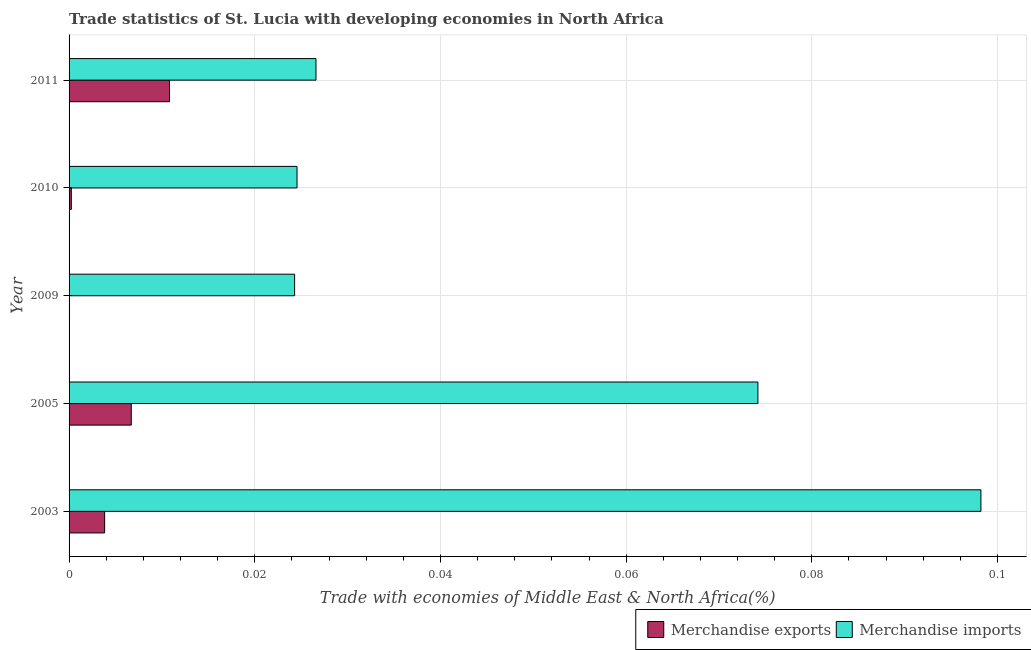How many groups of bars are there?
Ensure brevity in your answer.  5. Are the number of bars on each tick of the Y-axis equal?
Keep it short and to the point. Yes. How many bars are there on the 3rd tick from the top?
Your response must be concise. 2. How many bars are there on the 3rd tick from the bottom?
Your answer should be compact. 2. What is the label of the 1st group of bars from the top?
Your answer should be very brief. 2011. In how many cases, is the number of bars for a given year not equal to the number of legend labels?
Keep it short and to the point. 0. What is the merchandise imports in 2005?
Your answer should be very brief. 0.07. Across all years, what is the maximum merchandise imports?
Provide a succinct answer. 0.1. Across all years, what is the minimum merchandise imports?
Make the answer very short. 0.02. What is the total merchandise exports in the graph?
Ensure brevity in your answer.  0.02. What is the difference between the merchandise exports in 2009 and that in 2010?
Make the answer very short. -0. What is the difference between the merchandise exports in 2009 and the merchandise imports in 2003?
Make the answer very short. -0.1. What is the average merchandise imports per year?
Provide a short and direct response. 0.05. In the year 2003, what is the difference between the merchandise exports and merchandise imports?
Offer a terse response. -0.09. In how many years, is the merchandise exports greater than 0.056 %?
Your answer should be very brief. 0. What is the ratio of the merchandise exports in 2003 to that in 2009?
Ensure brevity in your answer.  79.5. Is the merchandise imports in 2003 less than that in 2009?
Offer a very short reply. No. What is the difference between the highest and the second highest merchandise exports?
Make the answer very short. 0. What is the difference between the highest and the lowest merchandise imports?
Make the answer very short. 0.07. Is the sum of the merchandise imports in 2005 and 2009 greater than the maximum merchandise exports across all years?
Ensure brevity in your answer.  Yes. What does the 2nd bar from the top in 2009 represents?
Make the answer very short. Merchandise exports. What does the 2nd bar from the bottom in 2011 represents?
Keep it short and to the point. Merchandise imports. Are all the bars in the graph horizontal?
Offer a very short reply. Yes. How many years are there in the graph?
Provide a succinct answer. 5. What is the difference between two consecutive major ticks on the X-axis?
Your response must be concise. 0.02. Does the graph contain any zero values?
Your answer should be very brief. No. Does the graph contain grids?
Your response must be concise. Yes. Where does the legend appear in the graph?
Keep it short and to the point. Bottom right. What is the title of the graph?
Provide a short and direct response. Trade statistics of St. Lucia with developing economies in North Africa. What is the label or title of the X-axis?
Make the answer very short. Trade with economies of Middle East & North Africa(%). What is the label or title of the Y-axis?
Your response must be concise. Year. What is the Trade with economies of Middle East & North Africa(%) in Merchandise exports in 2003?
Keep it short and to the point. 0. What is the Trade with economies of Middle East & North Africa(%) in Merchandise imports in 2003?
Provide a succinct answer. 0.1. What is the Trade with economies of Middle East & North Africa(%) of Merchandise exports in 2005?
Offer a terse response. 0.01. What is the Trade with economies of Middle East & North Africa(%) of Merchandise imports in 2005?
Give a very brief answer. 0.07. What is the Trade with economies of Middle East & North Africa(%) in Merchandise exports in 2009?
Keep it short and to the point. 4.81975497009493e-5. What is the Trade with economies of Middle East & North Africa(%) of Merchandise imports in 2009?
Your response must be concise. 0.02. What is the Trade with economies of Middle East & North Africa(%) of Merchandise exports in 2010?
Your answer should be very brief. 0. What is the Trade with economies of Middle East & North Africa(%) of Merchandise imports in 2010?
Make the answer very short. 0.02. What is the Trade with economies of Middle East & North Africa(%) of Merchandise exports in 2011?
Offer a terse response. 0.01. What is the Trade with economies of Middle East & North Africa(%) of Merchandise imports in 2011?
Keep it short and to the point. 0.03. Across all years, what is the maximum Trade with economies of Middle East & North Africa(%) in Merchandise exports?
Provide a succinct answer. 0.01. Across all years, what is the maximum Trade with economies of Middle East & North Africa(%) of Merchandise imports?
Your response must be concise. 0.1. Across all years, what is the minimum Trade with economies of Middle East & North Africa(%) in Merchandise exports?
Your answer should be very brief. 4.81975497009493e-5. Across all years, what is the minimum Trade with economies of Middle East & North Africa(%) of Merchandise imports?
Offer a terse response. 0.02. What is the total Trade with economies of Middle East & North Africa(%) of Merchandise exports in the graph?
Keep it short and to the point. 0.02. What is the total Trade with economies of Middle East & North Africa(%) in Merchandise imports in the graph?
Offer a very short reply. 0.25. What is the difference between the Trade with economies of Middle East & North Africa(%) of Merchandise exports in 2003 and that in 2005?
Give a very brief answer. -0. What is the difference between the Trade with economies of Middle East & North Africa(%) in Merchandise imports in 2003 and that in 2005?
Make the answer very short. 0.02. What is the difference between the Trade with economies of Middle East & North Africa(%) in Merchandise exports in 2003 and that in 2009?
Keep it short and to the point. 0. What is the difference between the Trade with economies of Middle East & North Africa(%) of Merchandise imports in 2003 and that in 2009?
Make the answer very short. 0.07. What is the difference between the Trade with economies of Middle East & North Africa(%) of Merchandise exports in 2003 and that in 2010?
Provide a short and direct response. 0. What is the difference between the Trade with economies of Middle East & North Africa(%) in Merchandise imports in 2003 and that in 2010?
Provide a succinct answer. 0.07. What is the difference between the Trade with economies of Middle East & North Africa(%) of Merchandise exports in 2003 and that in 2011?
Offer a very short reply. -0.01. What is the difference between the Trade with economies of Middle East & North Africa(%) of Merchandise imports in 2003 and that in 2011?
Provide a succinct answer. 0.07. What is the difference between the Trade with economies of Middle East & North Africa(%) in Merchandise exports in 2005 and that in 2009?
Ensure brevity in your answer.  0.01. What is the difference between the Trade with economies of Middle East & North Africa(%) of Merchandise imports in 2005 and that in 2009?
Offer a very short reply. 0.05. What is the difference between the Trade with economies of Middle East & North Africa(%) in Merchandise exports in 2005 and that in 2010?
Your answer should be compact. 0.01. What is the difference between the Trade with economies of Middle East & North Africa(%) in Merchandise imports in 2005 and that in 2010?
Give a very brief answer. 0.05. What is the difference between the Trade with economies of Middle East & North Africa(%) of Merchandise exports in 2005 and that in 2011?
Make the answer very short. -0. What is the difference between the Trade with economies of Middle East & North Africa(%) of Merchandise imports in 2005 and that in 2011?
Provide a succinct answer. 0.05. What is the difference between the Trade with economies of Middle East & North Africa(%) in Merchandise exports in 2009 and that in 2010?
Provide a succinct answer. -0. What is the difference between the Trade with economies of Middle East & North Africa(%) in Merchandise imports in 2009 and that in 2010?
Your answer should be very brief. -0. What is the difference between the Trade with economies of Middle East & North Africa(%) of Merchandise exports in 2009 and that in 2011?
Provide a succinct answer. -0.01. What is the difference between the Trade with economies of Middle East & North Africa(%) of Merchandise imports in 2009 and that in 2011?
Your response must be concise. -0. What is the difference between the Trade with economies of Middle East & North Africa(%) in Merchandise exports in 2010 and that in 2011?
Offer a very short reply. -0.01. What is the difference between the Trade with economies of Middle East & North Africa(%) of Merchandise imports in 2010 and that in 2011?
Provide a succinct answer. -0. What is the difference between the Trade with economies of Middle East & North Africa(%) in Merchandise exports in 2003 and the Trade with economies of Middle East & North Africa(%) in Merchandise imports in 2005?
Give a very brief answer. -0.07. What is the difference between the Trade with economies of Middle East & North Africa(%) in Merchandise exports in 2003 and the Trade with economies of Middle East & North Africa(%) in Merchandise imports in 2009?
Offer a very short reply. -0.02. What is the difference between the Trade with economies of Middle East & North Africa(%) in Merchandise exports in 2003 and the Trade with economies of Middle East & North Africa(%) in Merchandise imports in 2010?
Your answer should be compact. -0.02. What is the difference between the Trade with economies of Middle East & North Africa(%) in Merchandise exports in 2003 and the Trade with economies of Middle East & North Africa(%) in Merchandise imports in 2011?
Your answer should be very brief. -0.02. What is the difference between the Trade with economies of Middle East & North Africa(%) in Merchandise exports in 2005 and the Trade with economies of Middle East & North Africa(%) in Merchandise imports in 2009?
Provide a succinct answer. -0.02. What is the difference between the Trade with economies of Middle East & North Africa(%) in Merchandise exports in 2005 and the Trade with economies of Middle East & North Africa(%) in Merchandise imports in 2010?
Ensure brevity in your answer.  -0.02. What is the difference between the Trade with economies of Middle East & North Africa(%) of Merchandise exports in 2005 and the Trade with economies of Middle East & North Africa(%) of Merchandise imports in 2011?
Ensure brevity in your answer.  -0.02. What is the difference between the Trade with economies of Middle East & North Africa(%) of Merchandise exports in 2009 and the Trade with economies of Middle East & North Africa(%) of Merchandise imports in 2010?
Keep it short and to the point. -0.02. What is the difference between the Trade with economies of Middle East & North Africa(%) of Merchandise exports in 2009 and the Trade with economies of Middle East & North Africa(%) of Merchandise imports in 2011?
Your answer should be very brief. -0.03. What is the difference between the Trade with economies of Middle East & North Africa(%) of Merchandise exports in 2010 and the Trade with economies of Middle East & North Africa(%) of Merchandise imports in 2011?
Offer a terse response. -0.03. What is the average Trade with economies of Middle East & North Africa(%) in Merchandise exports per year?
Provide a short and direct response. 0. What is the average Trade with economies of Middle East & North Africa(%) of Merchandise imports per year?
Keep it short and to the point. 0.05. In the year 2003, what is the difference between the Trade with economies of Middle East & North Africa(%) in Merchandise exports and Trade with economies of Middle East & North Africa(%) in Merchandise imports?
Provide a short and direct response. -0.09. In the year 2005, what is the difference between the Trade with economies of Middle East & North Africa(%) of Merchandise exports and Trade with economies of Middle East & North Africa(%) of Merchandise imports?
Your response must be concise. -0.07. In the year 2009, what is the difference between the Trade with economies of Middle East & North Africa(%) of Merchandise exports and Trade with economies of Middle East & North Africa(%) of Merchandise imports?
Give a very brief answer. -0.02. In the year 2010, what is the difference between the Trade with economies of Middle East & North Africa(%) in Merchandise exports and Trade with economies of Middle East & North Africa(%) in Merchandise imports?
Provide a short and direct response. -0.02. In the year 2011, what is the difference between the Trade with economies of Middle East & North Africa(%) of Merchandise exports and Trade with economies of Middle East & North Africa(%) of Merchandise imports?
Your answer should be compact. -0.02. What is the ratio of the Trade with economies of Middle East & North Africa(%) in Merchandise exports in 2003 to that in 2005?
Make the answer very short. 0.57. What is the ratio of the Trade with economies of Middle East & North Africa(%) in Merchandise imports in 2003 to that in 2005?
Offer a very short reply. 1.32. What is the ratio of the Trade with economies of Middle East & North Africa(%) in Merchandise exports in 2003 to that in 2009?
Your answer should be compact. 79.5. What is the ratio of the Trade with economies of Middle East & North Africa(%) in Merchandise imports in 2003 to that in 2009?
Keep it short and to the point. 4.04. What is the ratio of the Trade with economies of Middle East & North Africa(%) in Merchandise exports in 2003 to that in 2010?
Offer a terse response. 15.83. What is the ratio of the Trade with economies of Middle East & North Africa(%) of Merchandise imports in 2003 to that in 2010?
Offer a terse response. 4. What is the ratio of the Trade with economies of Middle East & North Africa(%) in Merchandise exports in 2003 to that in 2011?
Your response must be concise. 0.35. What is the ratio of the Trade with economies of Middle East & North Africa(%) in Merchandise imports in 2003 to that in 2011?
Your answer should be very brief. 3.69. What is the ratio of the Trade with economies of Middle East & North Africa(%) in Merchandise exports in 2005 to that in 2009?
Ensure brevity in your answer.  139. What is the ratio of the Trade with economies of Middle East & North Africa(%) of Merchandise imports in 2005 to that in 2009?
Provide a succinct answer. 3.05. What is the ratio of the Trade with economies of Middle East & North Africa(%) in Merchandise exports in 2005 to that in 2010?
Your answer should be very brief. 27.67. What is the ratio of the Trade with economies of Middle East & North Africa(%) in Merchandise imports in 2005 to that in 2010?
Offer a very short reply. 3.02. What is the ratio of the Trade with economies of Middle East & North Africa(%) of Merchandise exports in 2005 to that in 2011?
Ensure brevity in your answer.  0.62. What is the ratio of the Trade with economies of Middle East & North Africa(%) in Merchandise imports in 2005 to that in 2011?
Provide a short and direct response. 2.79. What is the ratio of the Trade with economies of Middle East & North Africa(%) of Merchandise exports in 2009 to that in 2010?
Your answer should be compact. 0.2. What is the ratio of the Trade with economies of Middle East & North Africa(%) of Merchandise exports in 2009 to that in 2011?
Make the answer very short. 0. What is the ratio of the Trade with economies of Middle East & North Africa(%) in Merchandise imports in 2009 to that in 2011?
Provide a succinct answer. 0.91. What is the ratio of the Trade with economies of Middle East & North Africa(%) of Merchandise exports in 2010 to that in 2011?
Offer a very short reply. 0.02. What is the ratio of the Trade with economies of Middle East & North Africa(%) in Merchandise imports in 2010 to that in 2011?
Your answer should be very brief. 0.92. What is the difference between the highest and the second highest Trade with economies of Middle East & North Africa(%) in Merchandise exports?
Ensure brevity in your answer.  0. What is the difference between the highest and the second highest Trade with economies of Middle East & North Africa(%) of Merchandise imports?
Keep it short and to the point. 0.02. What is the difference between the highest and the lowest Trade with economies of Middle East & North Africa(%) of Merchandise exports?
Make the answer very short. 0.01. What is the difference between the highest and the lowest Trade with economies of Middle East & North Africa(%) of Merchandise imports?
Make the answer very short. 0.07. 